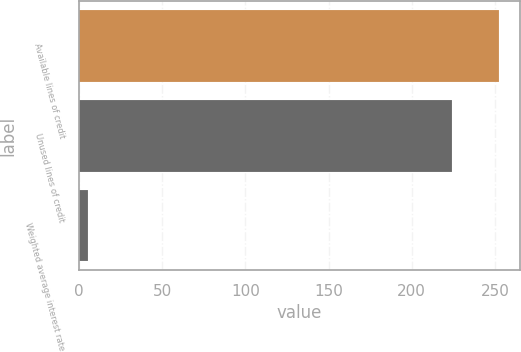Convert chart. <chart><loc_0><loc_0><loc_500><loc_500><bar_chart><fcel>Available lines of credit<fcel>Unused lines of credit<fcel>Weighted average interest rate<nl><fcel>252.6<fcel>224.4<fcel>5.5<nl></chart> 